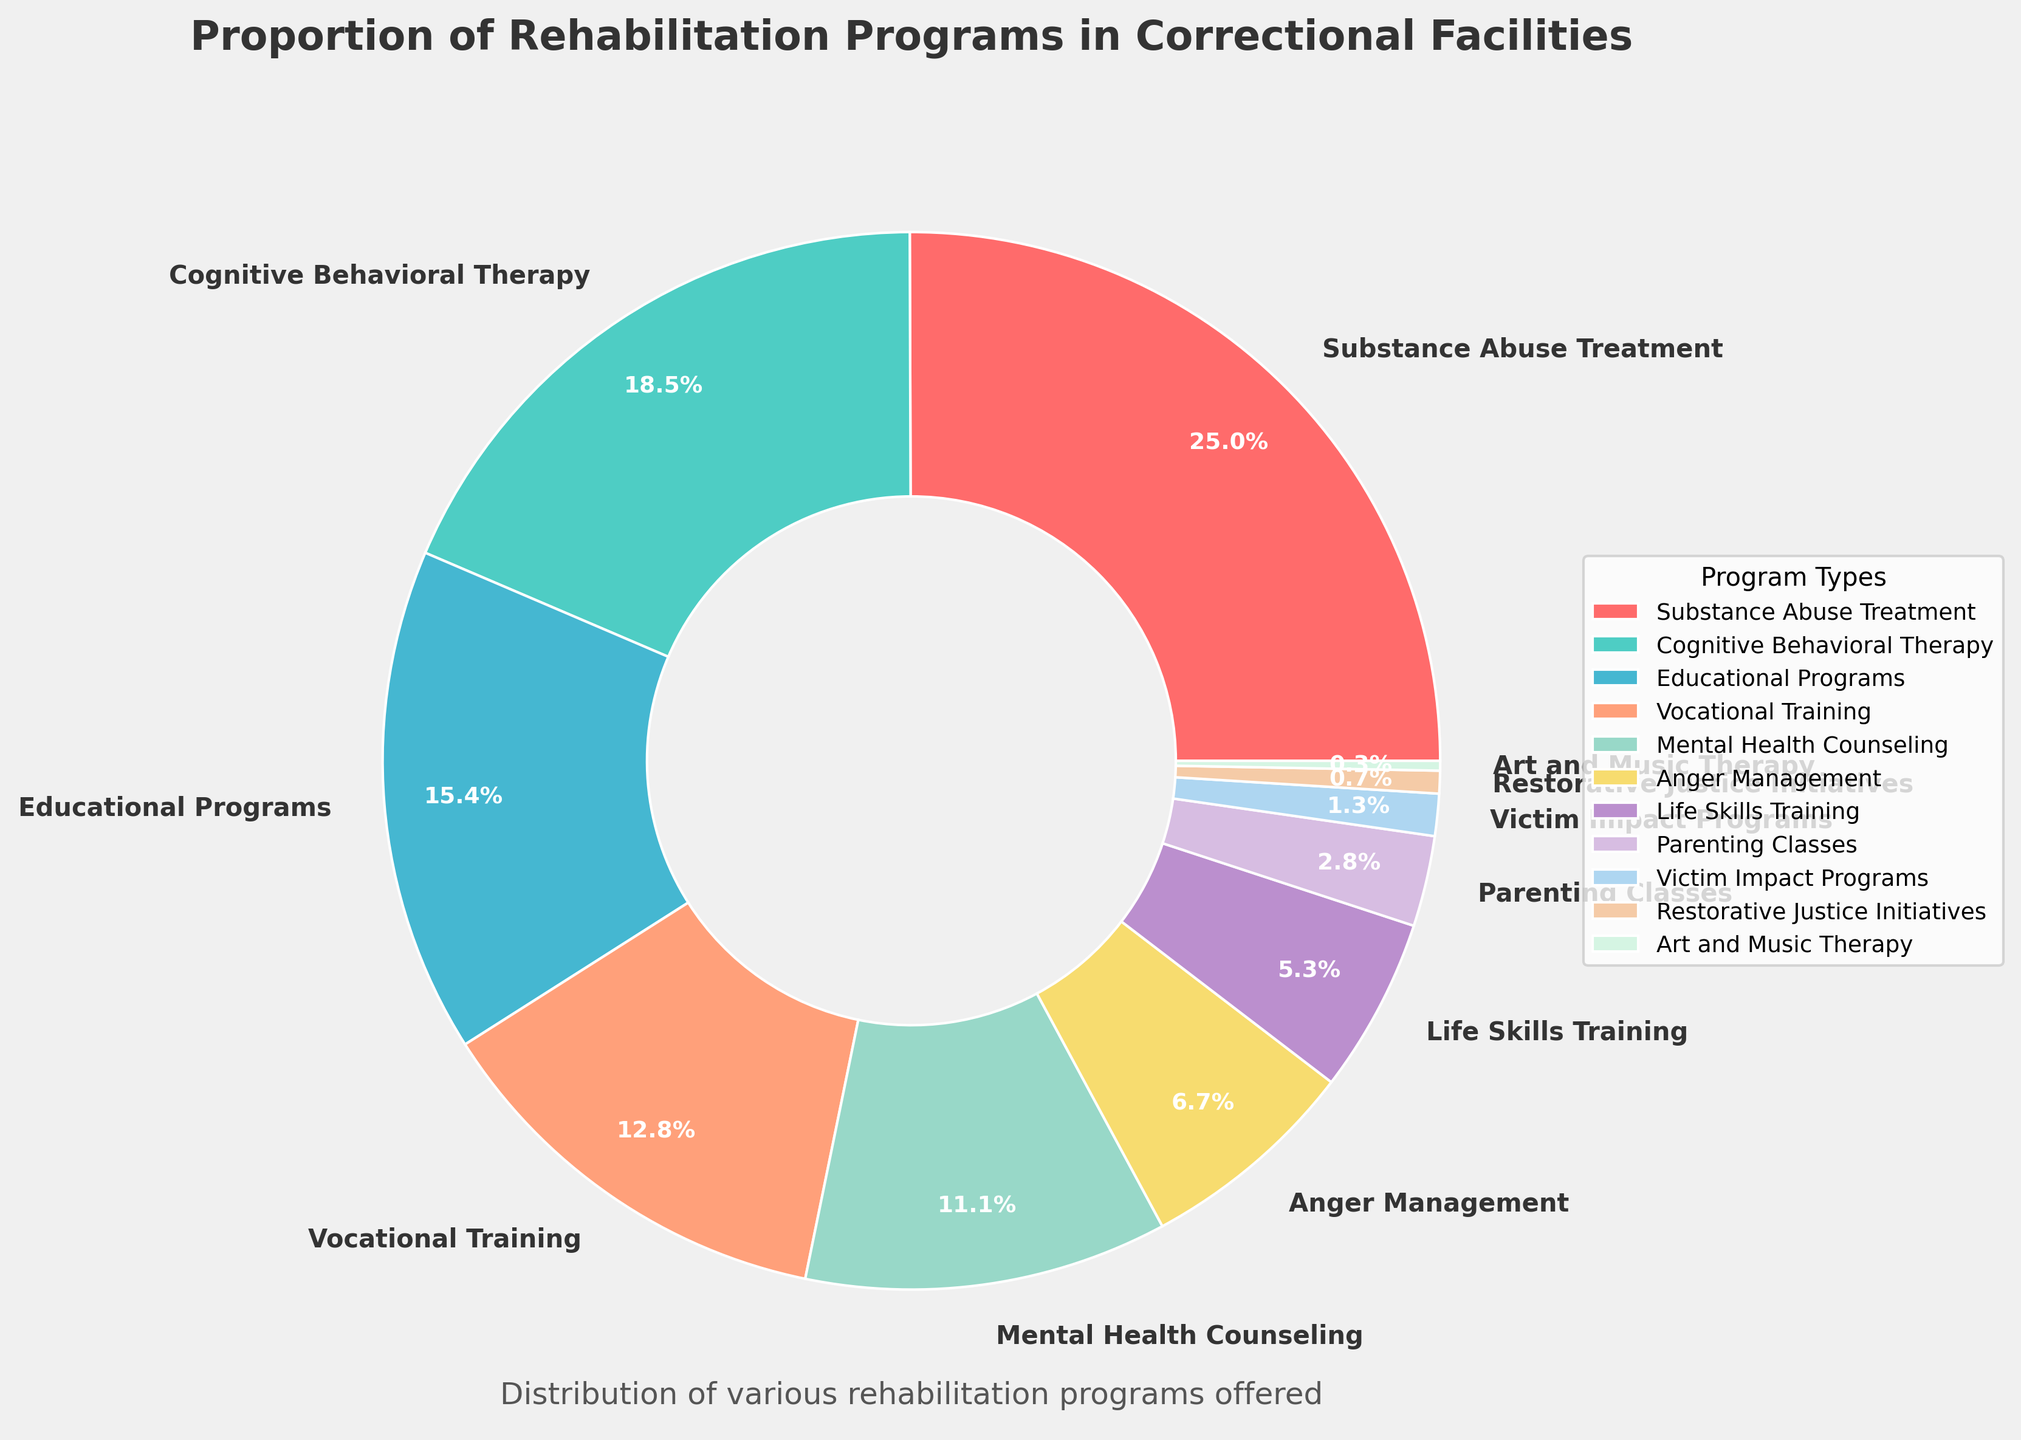What is the largest rehabilitation program offered in correctional facilities? By examining the pie chart, we can identify the segment with the largest percentage. The Substance Abuse Treatment program occupies the largest portion.
Answer: Substance Abuse Treatment Which program is offered less frequently: Anger Management or Educational Programs? Comparing the sizes of the slices labeled Anger Management and Educational Programs, the Anger Management slice is smaller.
Answer: Anger Management What is the combined percentage of Cognitive Behavioral Therapy, Educational Programs, and Vocational Training? Add the percentages of Cognitive Behavioral Therapy (18.7%), Educational Programs (15.6%), and Vocational Training (12.9%): 18.7 + 15.6 + 12.9 = 47.2%.
Answer: 47.2% How much larger is Substance Abuse Treatment compared to Mental Health Counseling? Subtract the percentage of Mental Health Counseling (11.2%) from the percentage of Substance Abuse Treatment (25.3%): 25.3 - 11.2 = 14.1%.
Answer: 14.1% Which program has the smallest proportion, and what is its percentage? The smallest slice of the pie chart corresponds to Art and Music Therapy.
Answer: Art and Music Therapy, 0.3% How does the percentage of Vocational Training compare to that of Life Skills Training? Comparing the slices, Vocational Training (12.9%) is larger than Life Skills Training (5.4%).
Answer: Vocational Training is larger What is the visual color associated with Educational Programs? The segment labeled Educational Programs is colored light orange.
Answer: Light orange What is the average percentage of the three smallest programs? The three smallest programs are Art and Music Therapy (0.3%), Restorative Justice Initiatives (0.7%), and Victim Impact Programs (1.3%). Calculate the average: (0.3 + 0.7 + 1.3) / 3 = 2.3 / 3 ≈ 0.77%.
Answer: 0.77% How many programs have a percentage greater than or equal to 10%? The programs are Substance Abuse Treatment (25.3%), Cognitive Behavioral Therapy (18.7%), Educational Programs (15.6%), Vocational Training (12.9%), and Mental Health Counseling (11.2%). Count them: there are 5 programs.
Answer: 5 programs What proportion of programs are under 5%? Sum the percentages of Life Skills Training (5.4%), Parenting Classes (2.8%), Victim Impact Programs (1.3%), Restorative Justice Initiatives (0.7%), and Art and Music Therapy (0.3%). Only 2 have percentages strictly under 5%: Parenting Classes, Victim Impact Programs, Restorative Justice Initiatives, and Art and Music Therapy.
Answer: 4 programs 